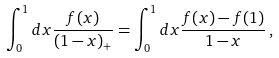Convert formula to latex. <formula><loc_0><loc_0><loc_500><loc_500>\int _ { 0 } ^ { 1 } d x \frac { f ( x ) } { ( 1 - x ) _ { + } } = \int _ { 0 } ^ { 1 } d x \frac { f ( x ) - f ( 1 ) } { 1 - x } \, ,</formula> 